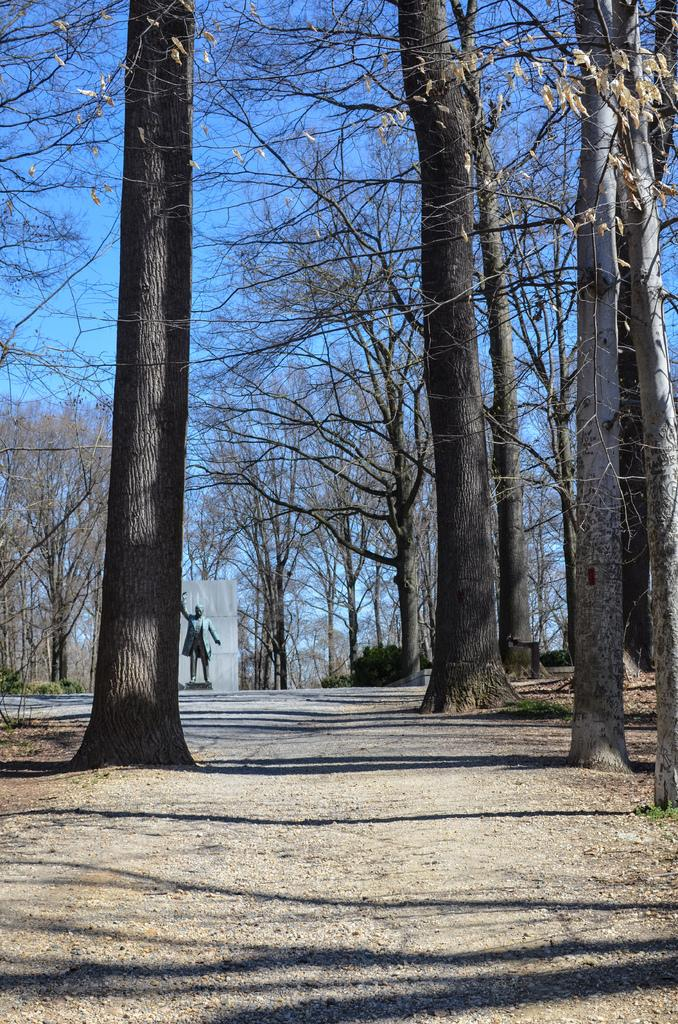What type of area is depicted in the image? There is an open ground in the image. What can be observed on the open ground? Shadows are visible on the open ground. What natural elements are present in the image? There are trees in the image. What can be seen in the background of the image? There is a sculpture and the sky visible in the background of the image. What type of jam is being spread on the seed in the image? There is no jam or seed present in the image; it features an open ground with shadows, trees, a sculpture, and the sky. 